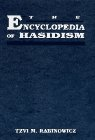Is this a religious book? Yes, it is a religious book. It delves into the spiritual teachings and practices of Hasidic Judaism, offering insights into its theological foundations and ritual observances. 